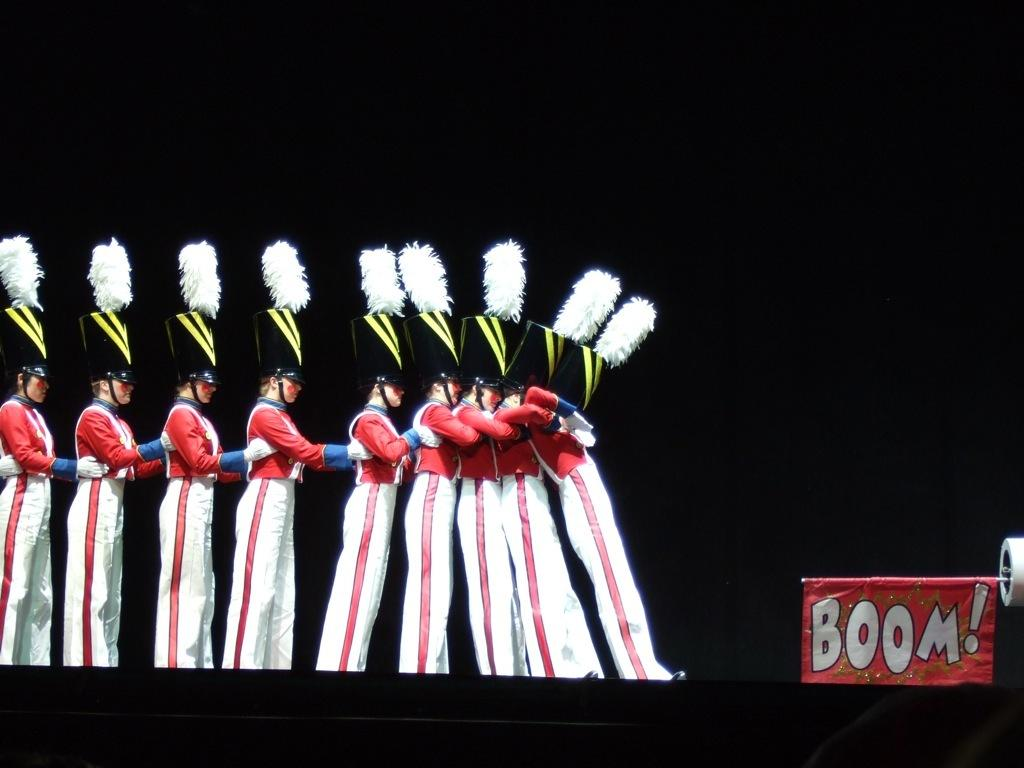What are the people in the image doing? The people are dancing on the stage. What are the people wearing on their heads? The people are wearing caps. Where is the banner located in the image? The banner is at the right bottom of the image. What color is the background of the image? The background of the image is black. What type of cheese is being judged in the scene? There is no cheese or judging activity present in the image; it features people dancing on the stage. 